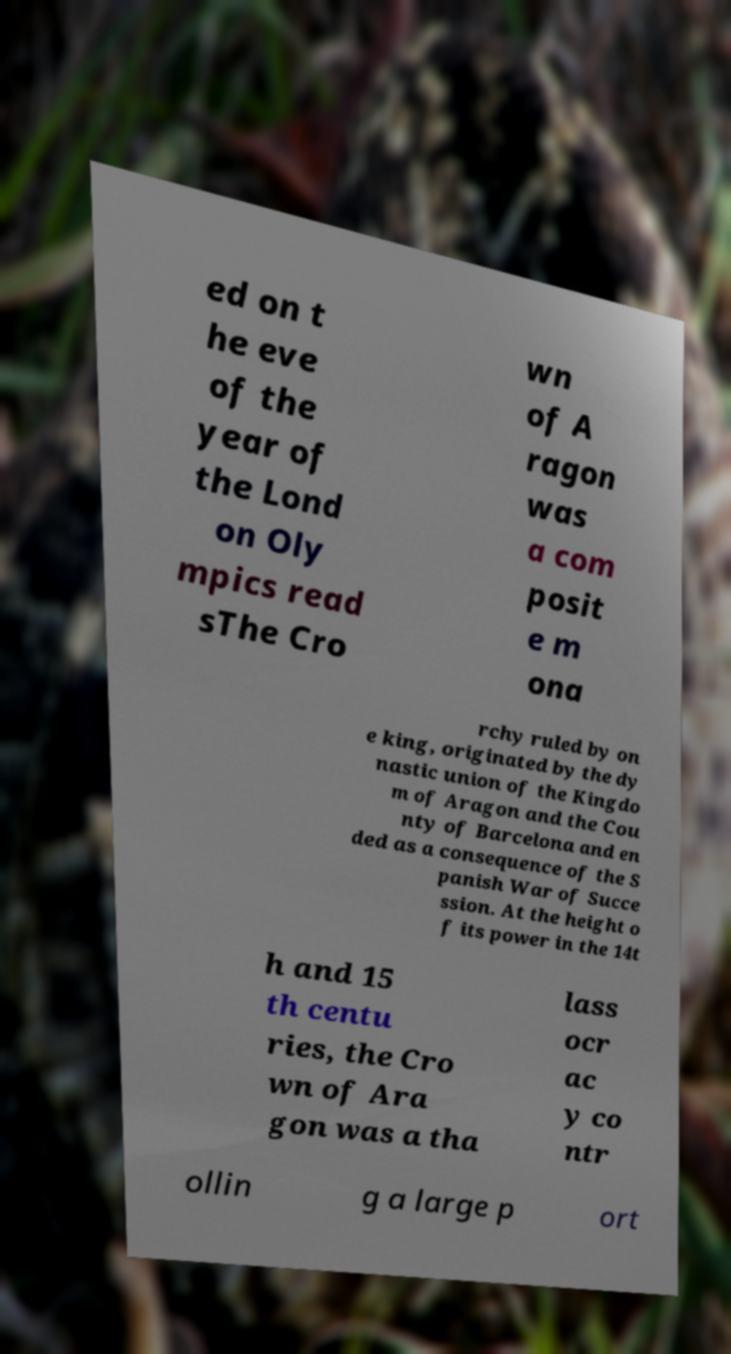Please identify and transcribe the text found in this image. ed on t he eve of the year of the Lond on Oly mpics read sThe Cro wn of A ragon was a com posit e m ona rchy ruled by on e king, originated by the dy nastic union of the Kingdo m of Aragon and the Cou nty of Barcelona and en ded as a consequence of the S panish War of Succe ssion. At the height o f its power in the 14t h and 15 th centu ries, the Cro wn of Ara gon was a tha lass ocr ac y co ntr ollin g a large p ort 